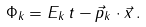<formula> <loc_0><loc_0><loc_500><loc_500>\Phi _ { k } = E _ { k } \, t - \vec { p } _ { k } \cdot \vec { x } \, .</formula> 